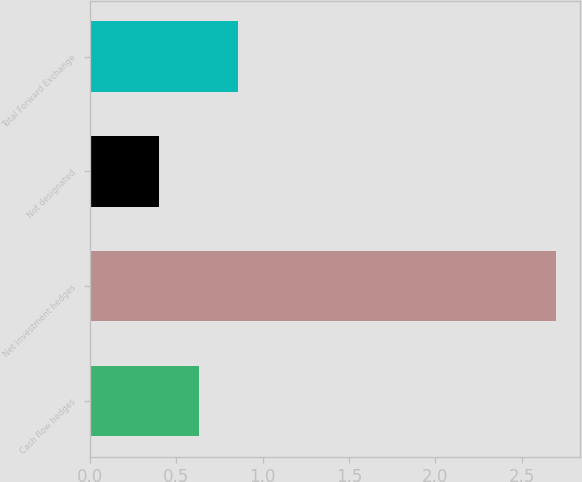Convert chart. <chart><loc_0><loc_0><loc_500><loc_500><bar_chart><fcel>Cash flow hedges<fcel>Net investment hedges<fcel>Not designated<fcel>Total Forward Exchange<nl><fcel>0.63<fcel>2.7<fcel>0.4<fcel>0.86<nl></chart> 